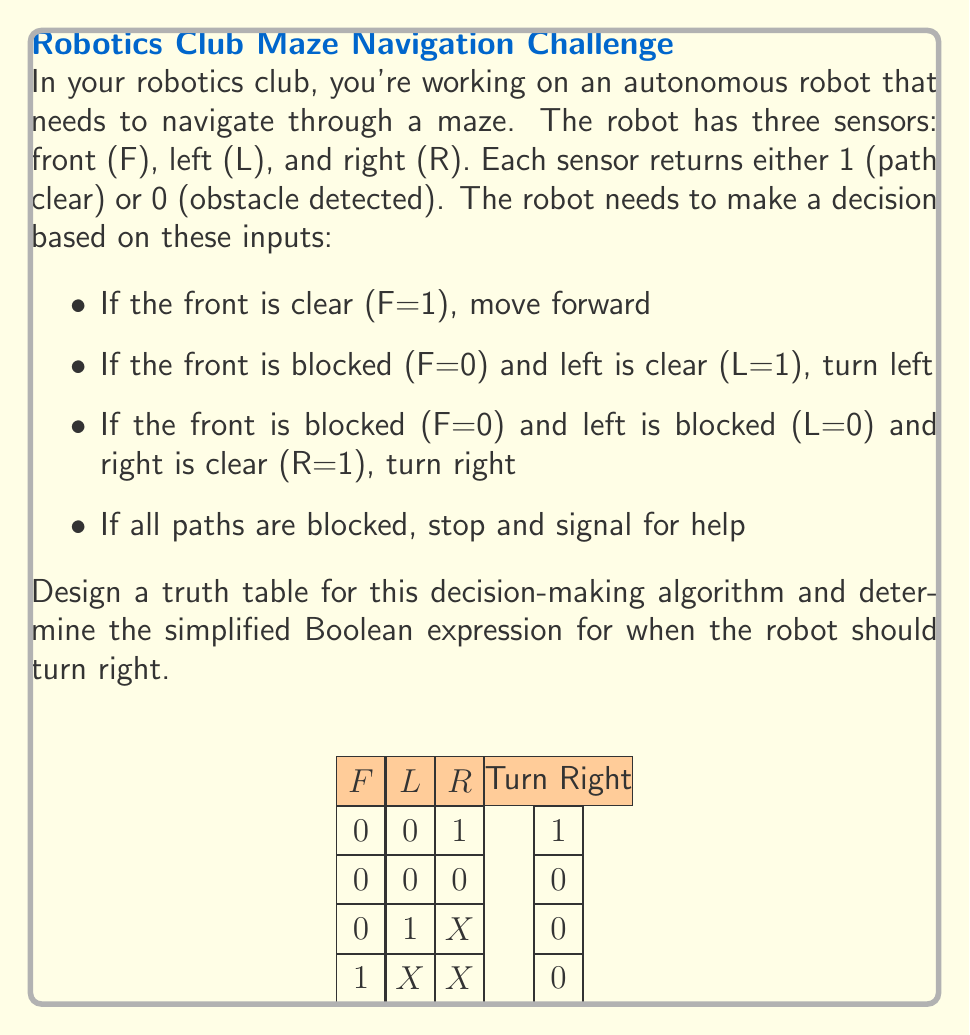Solve this math problem. Let's approach this step-by-step:

1) First, we need to create a complete truth table for all possible combinations of F, L, and R:

   F | L | R | Turn Right
   ----------------------
   0 | 0 | 0 | 0
   0 | 0 | 1 | 1
   0 | 1 | 0 | 0
   0 | 1 | 1 | 0
   1 | 0 | 0 | 0
   1 | 0 | 1 | 0
   1 | 1 | 0 | 0
   1 | 1 | 1 | 0

2) From the truth table, we can see that the robot turns right only when F=0, L=0, and R=1.

3) To get the Boolean expression for when the robot should turn right, we can use the product of these conditions:

   Turn Right = $\overline{F} \cdot \overline{L} \cdot R$

   Where $\overline{F}$ and $\overline{L}$ represent the negation of F and L respectively.

4) This expression is already in its simplest form, as it directly represents the single case where the robot should turn right.

5) In Boolean algebra, this can be written as:

   Turn Right = $F' \cdot L' \cdot R$

   Where $F'$ and $L'$ represent the negation of F and L respectively.

This simplified expression efficiently encodes the decision-making algorithm for when the robot should turn right, optimizing the autonomous navigation process.
Answer: $\overline{F} \cdot \overline{L} \cdot R$ 